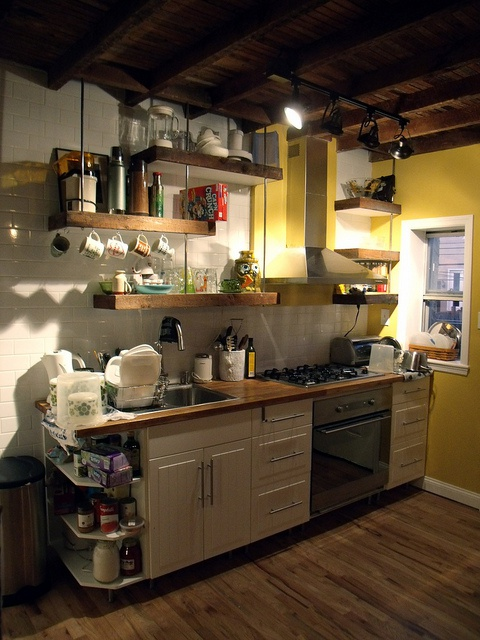Describe the objects in this image and their specific colors. I can see oven in black and gray tones, bottle in black, gray, darkgreen, and beige tones, bottle in black, maroon, and brown tones, bottle in black and gray tones, and bottle in black and gray tones in this image. 